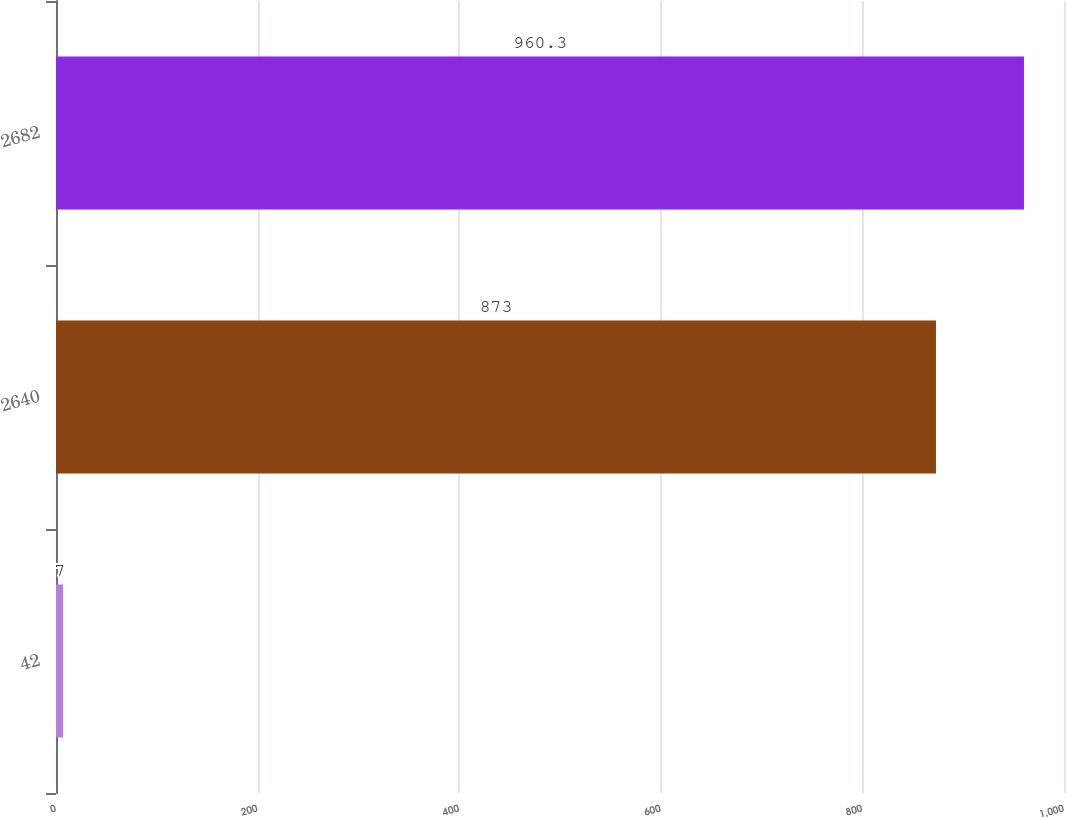Convert chart to OTSL. <chart><loc_0><loc_0><loc_500><loc_500><bar_chart><fcel>42<fcel>2640<fcel>2682<nl><fcel>7<fcel>873<fcel>960.3<nl></chart> 